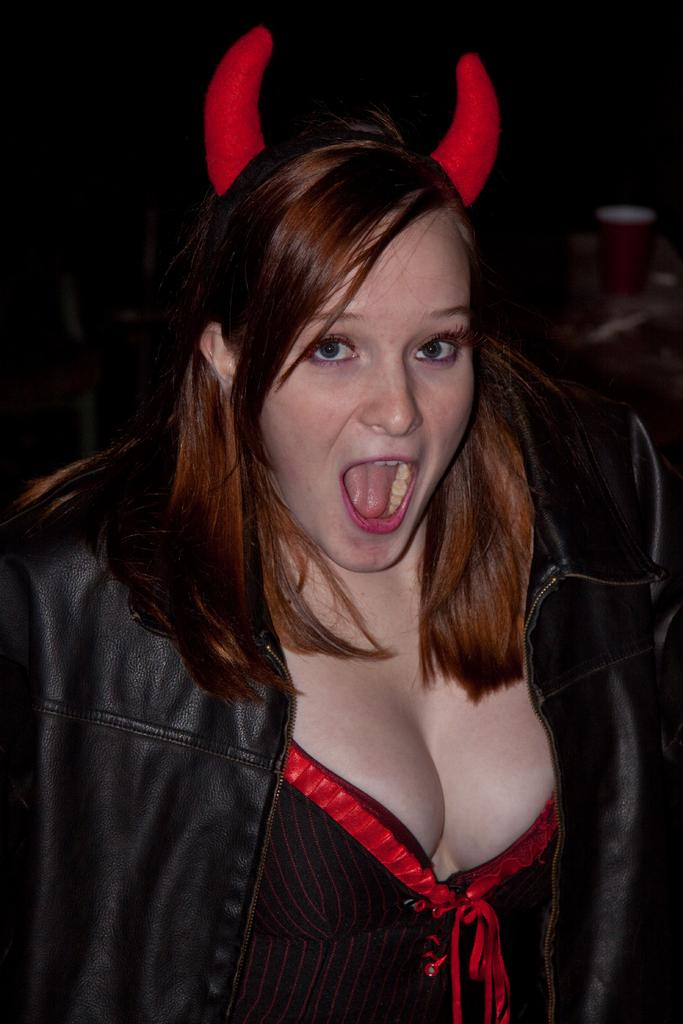Who is present in the image? There is a woman in the image. What is the woman wearing? The woman is wearing a jacket and horns. What can be observed about the background of the image? The background of the image is dark. How does the sink in the image contribute to the earthquake? There is no sink or earthquake present in the image; it features a woman wearing a jacket and horns against a dark background. 